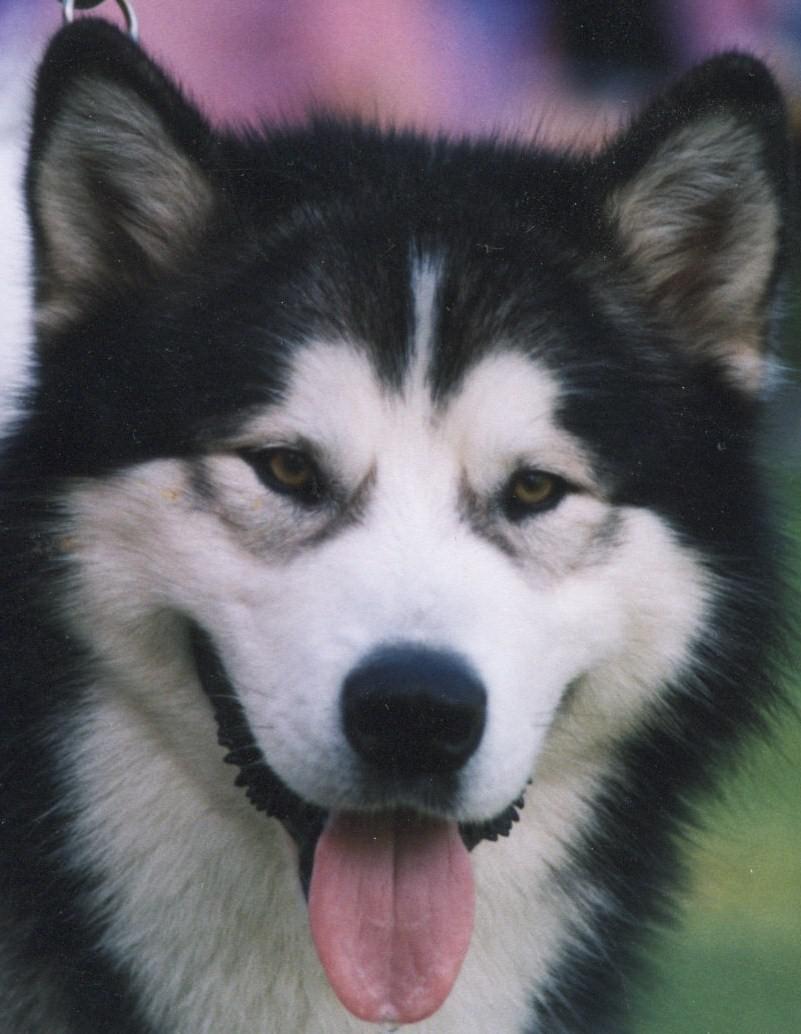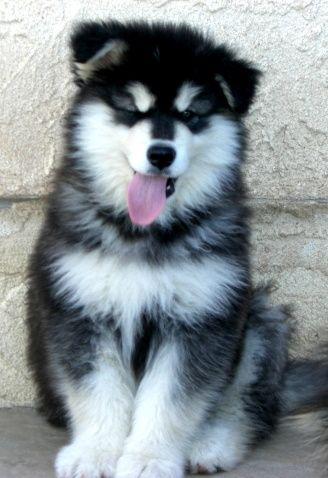The first image is the image on the left, the second image is the image on the right. Examine the images to the left and right. Is the description "there are two huskies with their tongue sticking out in the image pair" accurate? Answer yes or no. Yes. 